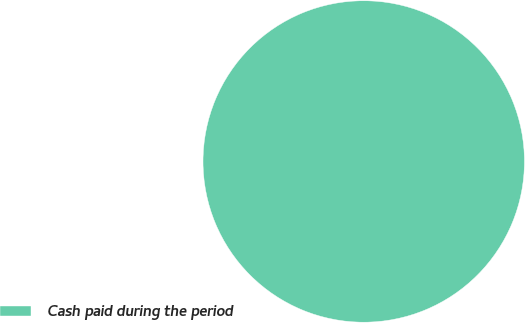<chart> <loc_0><loc_0><loc_500><loc_500><pie_chart><fcel>Cash paid during the period<nl><fcel>100.0%<nl></chart> 